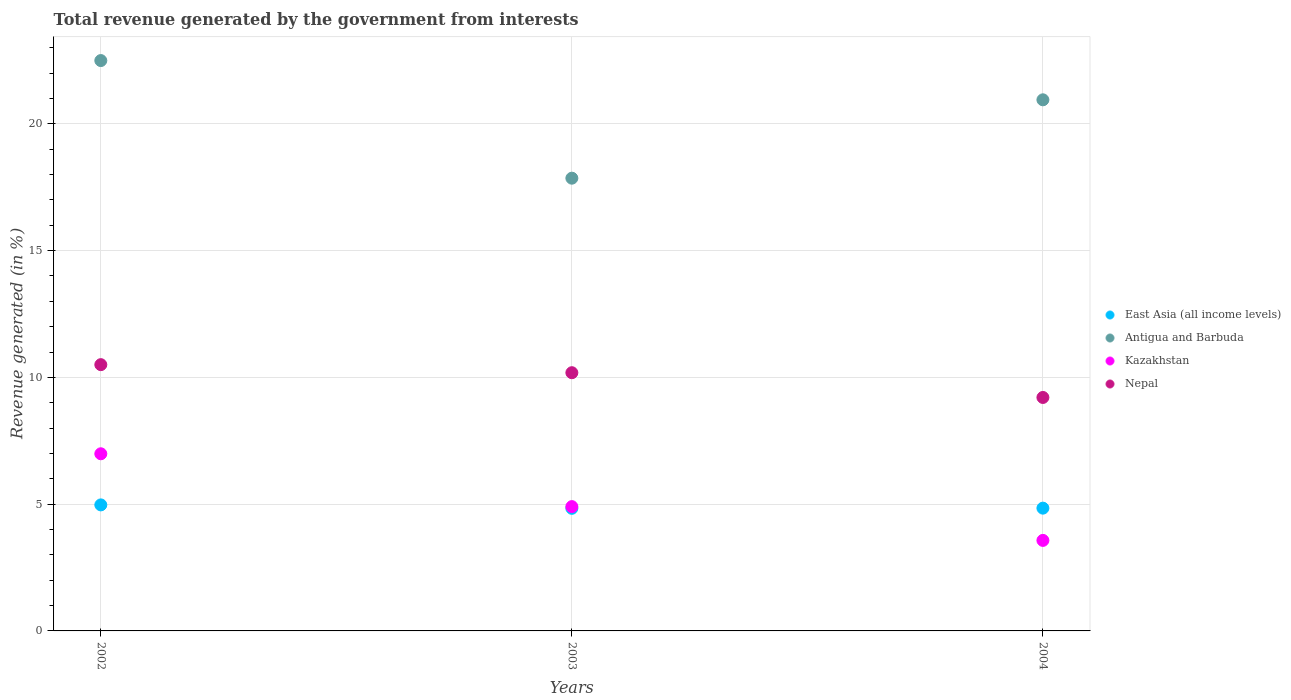How many different coloured dotlines are there?
Your response must be concise. 4. Is the number of dotlines equal to the number of legend labels?
Keep it short and to the point. Yes. What is the total revenue generated in Kazakhstan in 2002?
Keep it short and to the point. 6.99. Across all years, what is the maximum total revenue generated in East Asia (all income levels)?
Ensure brevity in your answer.  4.97. Across all years, what is the minimum total revenue generated in East Asia (all income levels)?
Ensure brevity in your answer.  4.84. What is the total total revenue generated in Antigua and Barbuda in the graph?
Ensure brevity in your answer.  61.3. What is the difference between the total revenue generated in Antigua and Barbuda in 2003 and that in 2004?
Make the answer very short. -3.09. What is the difference between the total revenue generated in Antigua and Barbuda in 2004 and the total revenue generated in Kazakhstan in 2003?
Keep it short and to the point. 16.05. What is the average total revenue generated in Kazakhstan per year?
Your answer should be very brief. 5.15. In the year 2003, what is the difference between the total revenue generated in Antigua and Barbuda and total revenue generated in Kazakhstan?
Give a very brief answer. 12.95. In how many years, is the total revenue generated in Nepal greater than 8 %?
Provide a succinct answer. 3. What is the ratio of the total revenue generated in Antigua and Barbuda in 2002 to that in 2003?
Offer a terse response. 1.26. Is the total revenue generated in Nepal in 2003 less than that in 2004?
Keep it short and to the point. No. Is the difference between the total revenue generated in Antigua and Barbuda in 2002 and 2003 greater than the difference between the total revenue generated in Kazakhstan in 2002 and 2003?
Keep it short and to the point. Yes. What is the difference between the highest and the second highest total revenue generated in Antigua and Barbuda?
Offer a very short reply. 1.55. What is the difference between the highest and the lowest total revenue generated in Kazakhstan?
Make the answer very short. 3.42. In how many years, is the total revenue generated in Nepal greater than the average total revenue generated in Nepal taken over all years?
Your response must be concise. 2. Is it the case that in every year, the sum of the total revenue generated in Antigua and Barbuda and total revenue generated in East Asia (all income levels)  is greater than the sum of total revenue generated in Nepal and total revenue generated in Kazakhstan?
Keep it short and to the point. Yes. Does the total revenue generated in East Asia (all income levels) monotonically increase over the years?
Provide a short and direct response. No. Is the total revenue generated in Antigua and Barbuda strictly greater than the total revenue generated in Nepal over the years?
Keep it short and to the point. Yes. Is the total revenue generated in Kazakhstan strictly less than the total revenue generated in East Asia (all income levels) over the years?
Provide a succinct answer. No. How many years are there in the graph?
Make the answer very short. 3. What is the difference between two consecutive major ticks on the Y-axis?
Make the answer very short. 5. Does the graph contain any zero values?
Make the answer very short. No. Does the graph contain grids?
Give a very brief answer. Yes. What is the title of the graph?
Your response must be concise. Total revenue generated by the government from interests. Does "Bahamas" appear as one of the legend labels in the graph?
Provide a succinct answer. No. What is the label or title of the Y-axis?
Provide a short and direct response. Revenue generated (in %). What is the Revenue generated (in %) of East Asia (all income levels) in 2002?
Offer a very short reply. 4.97. What is the Revenue generated (in %) of Antigua and Barbuda in 2002?
Your answer should be very brief. 22.5. What is the Revenue generated (in %) of Kazakhstan in 2002?
Make the answer very short. 6.99. What is the Revenue generated (in %) in Nepal in 2002?
Make the answer very short. 10.5. What is the Revenue generated (in %) of East Asia (all income levels) in 2003?
Provide a short and direct response. 4.84. What is the Revenue generated (in %) of Antigua and Barbuda in 2003?
Make the answer very short. 17.86. What is the Revenue generated (in %) of Kazakhstan in 2003?
Make the answer very short. 4.9. What is the Revenue generated (in %) of Nepal in 2003?
Provide a succinct answer. 10.18. What is the Revenue generated (in %) of East Asia (all income levels) in 2004?
Provide a succinct answer. 4.84. What is the Revenue generated (in %) of Antigua and Barbuda in 2004?
Ensure brevity in your answer.  20.95. What is the Revenue generated (in %) of Kazakhstan in 2004?
Offer a very short reply. 3.57. What is the Revenue generated (in %) in Nepal in 2004?
Give a very brief answer. 9.21. Across all years, what is the maximum Revenue generated (in %) of East Asia (all income levels)?
Offer a very short reply. 4.97. Across all years, what is the maximum Revenue generated (in %) of Antigua and Barbuda?
Provide a succinct answer. 22.5. Across all years, what is the maximum Revenue generated (in %) of Kazakhstan?
Offer a terse response. 6.99. Across all years, what is the maximum Revenue generated (in %) in Nepal?
Offer a very short reply. 10.5. Across all years, what is the minimum Revenue generated (in %) of East Asia (all income levels)?
Make the answer very short. 4.84. Across all years, what is the minimum Revenue generated (in %) of Antigua and Barbuda?
Your response must be concise. 17.86. Across all years, what is the minimum Revenue generated (in %) of Kazakhstan?
Give a very brief answer. 3.57. Across all years, what is the minimum Revenue generated (in %) in Nepal?
Ensure brevity in your answer.  9.21. What is the total Revenue generated (in %) in East Asia (all income levels) in the graph?
Offer a very short reply. 14.65. What is the total Revenue generated (in %) in Antigua and Barbuda in the graph?
Provide a short and direct response. 61.3. What is the total Revenue generated (in %) of Kazakhstan in the graph?
Your answer should be very brief. 15.46. What is the total Revenue generated (in %) of Nepal in the graph?
Your answer should be compact. 29.9. What is the difference between the Revenue generated (in %) of East Asia (all income levels) in 2002 and that in 2003?
Your answer should be compact. 0.14. What is the difference between the Revenue generated (in %) in Antigua and Barbuda in 2002 and that in 2003?
Offer a very short reply. 4.64. What is the difference between the Revenue generated (in %) in Kazakhstan in 2002 and that in 2003?
Ensure brevity in your answer.  2.08. What is the difference between the Revenue generated (in %) of Nepal in 2002 and that in 2003?
Offer a very short reply. 0.32. What is the difference between the Revenue generated (in %) of East Asia (all income levels) in 2002 and that in 2004?
Offer a very short reply. 0.13. What is the difference between the Revenue generated (in %) in Antigua and Barbuda in 2002 and that in 2004?
Offer a very short reply. 1.55. What is the difference between the Revenue generated (in %) in Kazakhstan in 2002 and that in 2004?
Ensure brevity in your answer.  3.42. What is the difference between the Revenue generated (in %) in Nepal in 2002 and that in 2004?
Make the answer very short. 1.29. What is the difference between the Revenue generated (in %) in East Asia (all income levels) in 2003 and that in 2004?
Your response must be concise. -0.01. What is the difference between the Revenue generated (in %) in Antigua and Barbuda in 2003 and that in 2004?
Provide a succinct answer. -3.09. What is the difference between the Revenue generated (in %) of Kazakhstan in 2003 and that in 2004?
Keep it short and to the point. 1.33. What is the difference between the Revenue generated (in %) of Nepal in 2003 and that in 2004?
Make the answer very short. 0.98. What is the difference between the Revenue generated (in %) of East Asia (all income levels) in 2002 and the Revenue generated (in %) of Antigua and Barbuda in 2003?
Your response must be concise. -12.89. What is the difference between the Revenue generated (in %) of East Asia (all income levels) in 2002 and the Revenue generated (in %) of Kazakhstan in 2003?
Offer a very short reply. 0.07. What is the difference between the Revenue generated (in %) in East Asia (all income levels) in 2002 and the Revenue generated (in %) in Nepal in 2003?
Offer a terse response. -5.21. What is the difference between the Revenue generated (in %) in Antigua and Barbuda in 2002 and the Revenue generated (in %) in Kazakhstan in 2003?
Your answer should be compact. 17.59. What is the difference between the Revenue generated (in %) of Antigua and Barbuda in 2002 and the Revenue generated (in %) of Nepal in 2003?
Provide a short and direct response. 12.31. What is the difference between the Revenue generated (in %) in Kazakhstan in 2002 and the Revenue generated (in %) in Nepal in 2003?
Your answer should be compact. -3.2. What is the difference between the Revenue generated (in %) of East Asia (all income levels) in 2002 and the Revenue generated (in %) of Antigua and Barbuda in 2004?
Keep it short and to the point. -15.98. What is the difference between the Revenue generated (in %) in East Asia (all income levels) in 2002 and the Revenue generated (in %) in Kazakhstan in 2004?
Provide a succinct answer. 1.4. What is the difference between the Revenue generated (in %) of East Asia (all income levels) in 2002 and the Revenue generated (in %) of Nepal in 2004?
Make the answer very short. -4.24. What is the difference between the Revenue generated (in %) in Antigua and Barbuda in 2002 and the Revenue generated (in %) in Kazakhstan in 2004?
Your response must be concise. 18.93. What is the difference between the Revenue generated (in %) in Antigua and Barbuda in 2002 and the Revenue generated (in %) in Nepal in 2004?
Offer a terse response. 13.29. What is the difference between the Revenue generated (in %) in Kazakhstan in 2002 and the Revenue generated (in %) in Nepal in 2004?
Keep it short and to the point. -2.22. What is the difference between the Revenue generated (in %) in East Asia (all income levels) in 2003 and the Revenue generated (in %) in Antigua and Barbuda in 2004?
Provide a succinct answer. -16.11. What is the difference between the Revenue generated (in %) of East Asia (all income levels) in 2003 and the Revenue generated (in %) of Kazakhstan in 2004?
Offer a very short reply. 1.27. What is the difference between the Revenue generated (in %) in East Asia (all income levels) in 2003 and the Revenue generated (in %) in Nepal in 2004?
Your response must be concise. -4.37. What is the difference between the Revenue generated (in %) of Antigua and Barbuda in 2003 and the Revenue generated (in %) of Kazakhstan in 2004?
Make the answer very short. 14.29. What is the difference between the Revenue generated (in %) in Antigua and Barbuda in 2003 and the Revenue generated (in %) in Nepal in 2004?
Provide a short and direct response. 8.65. What is the difference between the Revenue generated (in %) in Kazakhstan in 2003 and the Revenue generated (in %) in Nepal in 2004?
Your response must be concise. -4.31. What is the average Revenue generated (in %) in East Asia (all income levels) per year?
Provide a short and direct response. 4.88. What is the average Revenue generated (in %) of Antigua and Barbuda per year?
Your response must be concise. 20.43. What is the average Revenue generated (in %) in Kazakhstan per year?
Your answer should be compact. 5.15. What is the average Revenue generated (in %) in Nepal per year?
Give a very brief answer. 9.97. In the year 2002, what is the difference between the Revenue generated (in %) in East Asia (all income levels) and Revenue generated (in %) in Antigua and Barbuda?
Your answer should be very brief. -17.53. In the year 2002, what is the difference between the Revenue generated (in %) of East Asia (all income levels) and Revenue generated (in %) of Kazakhstan?
Ensure brevity in your answer.  -2.02. In the year 2002, what is the difference between the Revenue generated (in %) in East Asia (all income levels) and Revenue generated (in %) in Nepal?
Your answer should be very brief. -5.53. In the year 2002, what is the difference between the Revenue generated (in %) of Antigua and Barbuda and Revenue generated (in %) of Kazakhstan?
Provide a short and direct response. 15.51. In the year 2002, what is the difference between the Revenue generated (in %) of Antigua and Barbuda and Revenue generated (in %) of Nepal?
Your response must be concise. 11.99. In the year 2002, what is the difference between the Revenue generated (in %) in Kazakhstan and Revenue generated (in %) in Nepal?
Your response must be concise. -3.52. In the year 2003, what is the difference between the Revenue generated (in %) of East Asia (all income levels) and Revenue generated (in %) of Antigua and Barbuda?
Give a very brief answer. -13.02. In the year 2003, what is the difference between the Revenue generated (in %) of East Asia (all income levels) and Revenue generated (in %) of Kazakhstan?
Your response must be concise. -0.07. In the year 2003, what is the difference between the Revenue generated (in %) of East Asia (all income levels) and Revenue generated (in %) of Nepal?
Offer a terse response. -5.35. In the year 2003, what is the difference between the Revenue generated (in %) of Antigua and Barbuda and Revenue generated (in %) of Kazakhstan?
Provide a short and direct response. 12.95. In the year 2003, what is the difference between the Revenue generated (in %) in Antigua and Barbuda and Revenue generated (in %) in Nepal?
Provide a short and direct response. 7.67. In the year 2003, what is the difference between the Revenue generated (in %) in Kazakhstan and Revenue generated (in %) in Nepal?
Your answer should be very brief. -5.28. In the year 2004, what is the difference between the Revenue generated (in %) of East Asia (all income levels) and Revenue generated (in %) of Antigua and Barbuda?
Keep it short and to the point. -16.11. In the year 2004, what is the difference between the Revenue generated (in %) in East Asia (all income levels) and Revenue generated (in %) in Kazakhstan?
Provide a short and direct response. 1.27. In the year 2004, what is the difference between the Revenue generated (in %) in East Asia (all income levels) and Revenue generated (in %) in Nepal?
Your answer should be compact. -4.37. In the year 2004, what is the difference between the Revenue generated (in %) in Antigua and Barbuda and Revenue generated (in %) in Kazakhstan?
Provide a succinct answer. 17.38. In the year 2004, what is the difference between the Revenue generated (in %) of Antigua and Barbuda and Revenue generated (in %) of Nepal?
Your response must be concise. 11.74. In the year 2004, what is the difference between the Revenue generated (in %) in Kazakhstan and Revenue generated (in %) in Nepal?
Give a very brief answer. -5.64. What is the ratio of the Revenue generated (in %) of East Asia (all income levels) in 2002 to that in 2003?
Keep it short and to the point. 1.03. What is the ratio of the Revenue generated (in %) in Antigua and Barbuda in 2002 to that in 2003?
Give a very brief answer. 1.26. What is the ratio of the Revenue generated (in %) of Kazakhstan in 2002 to that in 2003?
Ensure brevity in your answer.  1.43. What is the ratio of the Revenue generated (in %) in Nepal in 2002 to that in 2003?
Your answer should be compact. 1.03. What is the ratio of the Revenue generated (in %) in East Asia (all income levels) in 2002 to that in 2004?
Give a very brief answer. 1.03. What is the ratio of the Revenue generated (in %) of Antigua and Barbuda in 2002 to that in 2004?
Your response must be concise. 1.07. What is the ratio of the Revenue generated (in %) of Kazakhstan in 2002 to that in 2004?
Your answer should be very brief. 1.96. What is the ratio of the Revenue generated (in %) in Nepal in 2002 to that in 2004?
Offer a terse response. 1.14. What is the ratio of the Revenue generated (in %) of East Asia (all income levels) in 2003 to that in 2004?
Ensure brevity in your answer.  1. What is the ratio of the Revenue generated (in %) of Antigua and Barbuda in 2003 to that in 2004?
Keep it short and to the point. 0.85. What is the ratio of the Revenue generated (in %) in Kazakhstan in 2003 to that in 2004?
Your response must be concise. 1.37. What is the ratio of the Revenue generated (in %) of Nepal in 2003 to that in 2004?
Offer a terse response. 1.11. What is the difference between the highest and the second highest Revenue generated (in %) in East Asia (all income levels)?
Provide a succinct answer. 0.13. What is the difference between the highest and the second highest Revenue generated (in %) of Antigua and Barbuda?
Make the answer very short. 1.55. What is the difference between the highest and the second highest Revenue generated (in %) of Kazakhstan?
Make the answer very short. 2.08. What is the difference between the highest and the second highest Revenue generated (in %) of Nepal?
Provide a short and direct response. 0.32. What is the difference between the highest and the lowest Revenue generated (in %) in East Asia (all income levels)?
Provide a succinct answer. 0.14. What is the difference between the highest and the lowest Revenue generated (in %) of Antigua and Barbuda?
Give a very brief answer. 4.64. What is the difference between the highest and the lowest Revenue generated (in %) of Kazakhstan?
Offer a very short reply. 3.42. What is the difference between the highest and the lowest Revenue generated (in %) of Nepal?
Provide a succinct answer. 1.29. 